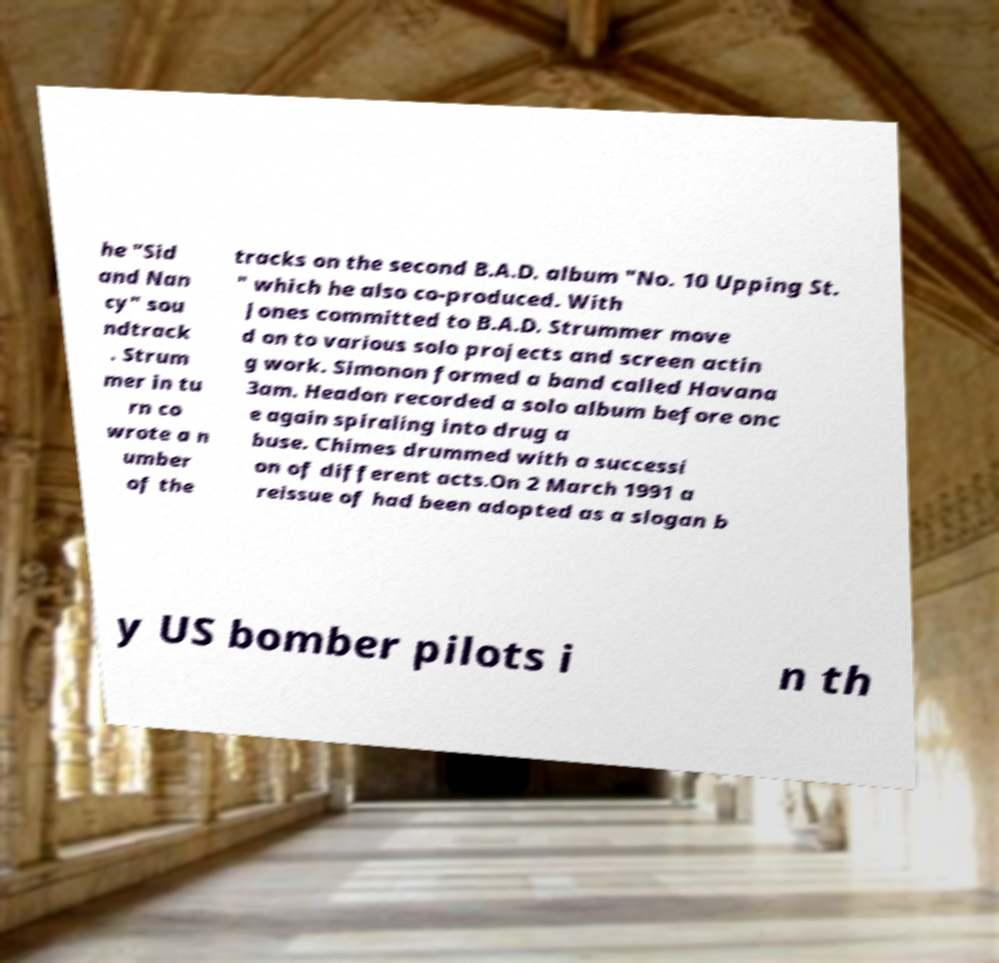Please identify and transcribe the text found in this image. he "Sid and Nan cy" sou ndtrack . Strum mer in tu rn co wrote a n umber of the tracks on the second B.A.D. album "No. 10 Upping St. " which he also co-produced. With Jones committed to B.A.D. Strummer move d on to various solo projects and screen actin g work. Simonon formed a band called Havana 3am. Headon recorded a solo album before onc e again spiraling into drug a buse. Chimes drummed with a successi on of different acts.On 2 March 1991 a reissue of had been adopted as a slogan b y US bomber pilots i n th 